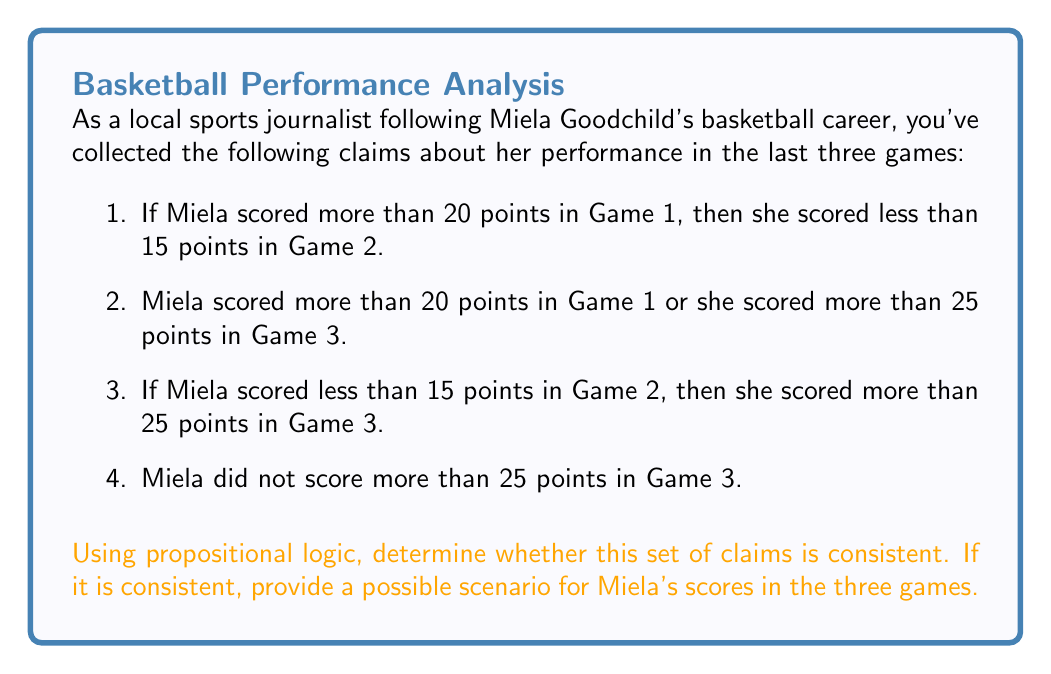Teach me how to tackle this problem. Let's approach this step-by-step using propositional logic:

1) Let's define our propositions:
   $P$: Miela scored more than 20 points in Game 1
   $Q$: Miela scored less than 15 points in Game 2
   $R$: Miela scored more than 25 points in Game 3

2) Now, let's translate the claims into logical statements:
   Claim 1: $P \rightarrow Q$
   Claim 2: $P \lor R$
   Claim 3: $Q \rightarrow R$
   Claim 4: $\neg R$

3) To check for consistency, we need to see if there's a way to assign truth values to $P$, $Q$, and $R$ that makes all statements true.

4) Let's start with Claim 4: $\neg R$ must be true, so $R$ must be false.

5) Given $R$ is false, for Claim 2 to be true, $P$ must be true.

6) Since $P$ is true, Claim 1 implies that $Q$ must be true.

7) Now, let's check Claim 3: $Q \rightarrow R$. We have $Q$ true and $R$ false. This is the only contradiction in our logic.

8) However, this contradiction can be resolved if we consider that $Q \rightarrow R$ is still true when $Q$ is false, regardless of the truth value of $R$.

9) Therefore, if we assign $P$ true, $Q$ false, and $R$ false, all claims are consistent.

This translates to the following scenario:
- Game 1: Miela scored more than 20 points
- Game 2: Miela scored 15 points or more (but not necessarily over 20)
- Game 3: Miela scored 25 points or less
Answer: Consistent; $P$ true, $Q$ false, $R$ false 